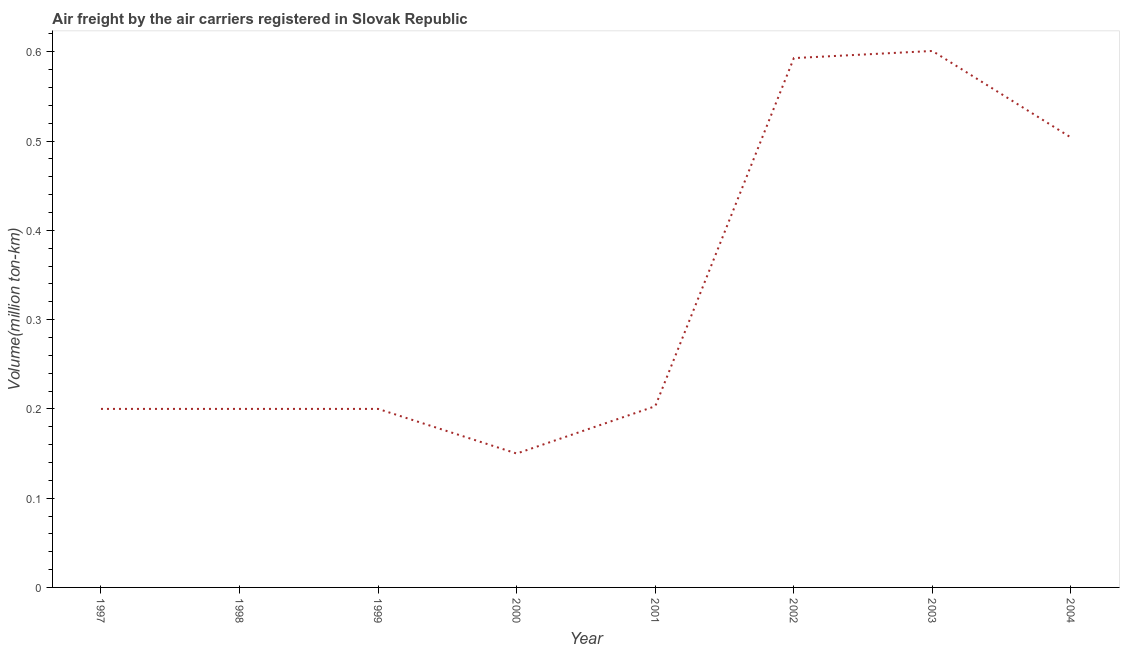What is the air freight in 2002?
Ensure brevity in your answer.  0.59. Across all years, what is the maximum air freight?
Keep it short and to the point. 0.6. In which year was the air freight minimum?
Ensure brevity in your answer.  2000. What is the sum of the air freight?
Keep it short and to the point. 2.65. What is the difference between the air freight in 2002 and 2004?
Make the answer very short. 0.09. What is the average air freight per year?
Make the answer very short. 0.33. What is the median air freight?
Ensure brevity in your answer.  0.2. In how many years, is the air freight greater than 0.18 million ton-km?
Keep it short and to the point. 7. What is the ratio of the air freight in 2000 to that in 2001?
Offer a very short reply. 0.74. Is the difference between the air freight in 1999 and 2002 greater than the difference between any two years?
Provide a succinct answer. No. What is the difference between the highest and the second highest air freight?
Your answer should be very brief. 0.01. Is the sum of the air freight in 2001 and 2003 greater than the maximum air freight across all years?
Offer a very short reply. Yes. What is the difference between the highest and the lowest air freight?
Provide a succinct answer. 0.45. In how many years, is the air freight greater than the average air freight taken over all years?
Offer a terse response. 3. Does the air freight monotonically increase over the years?
Offer a terse response. No. Does the graph contain any zero values?
Provide a succinct answer. No. What is the title of the graph?
Make the answer very short. Air freight by the air carriers registered in Slovak Republic. What is the label or title of the Y-axis?
Provide a short and direct response. Volume(million ton-km). What is the Volume(million ton-km) of 1997?
Keep it short and to the point. 0.2. What is the Volume(million ton-km) of 1998?
Offer a terse response. 0.2. What is the Volume(million ton-km) in 1999?
Your answer should be very brief. 0.2. What is the Volume(million ton-km) in 2001?
Your answer should be very brief. 0.2. What is the Volume(million ton-km) of 2002?
Give a very brief answer. 0.59. What is the Volume(million ton-km) in 2003?
Your answer should be compact. 0.6. What is the Volume(million ton-km) of 2004?
Keep it short and to the point. 0.5. What is the difference between the Volume(million ton-km) in 1997 and 2000?
Offer a very short reply. 0.05. What is the difference between the Volume(million ton-km) in 1997 and 2001?
Provide a succinct answer. -0. What is the difference between the Volume(million ton-km) in 1997 and 2002?
Your response must be concise. -0.39. What is the difference between the Volume(million ton-km) in 1997 and 2003?
Offer a terse response. -0.4. What is the difference between the Volume(million ton-km) in 1997 and 2004?
Offer a terse response. -0.3. What is the difference between the Volume(million ton-km) in 1998 and 1999?
Provide a short and direct response. 0. What is the difference between the Volume(million ton-km) in 1998 and 2000?
Keep it short and to the point. 0.05. What is the difference between the Volume(million ton-km) in 1998 and 2001?
Keep it short and to the point. -0. What is the difference between the Volume(million ton-km) in 1998 and 2002?
Your answer should be compact. -0.39. What is the difference between the Volume(million ton-km) in 1998 and 2003?
Your response must be concise. -0.4. What is the difference between the Volume(million ton-km) in 1998 and 2004?
Give a very brief answer. -0.3. What is the difference between the Volume(million ton-km) in 1999 and 2000?
Your answer should be compact. 0.05. What is the difference between the Volume(million ton-km) in 1999 and 2001?
Keep it short and to the point. -0. What is the difference between the Volume(million ton-km) in 1999 and 2002?
Your answer should be very brief. -0.39. What is the difference between the Volume(million ton-km) in 1999 and 2003?
Ensure brevity in your answer.  -0.4. What is the difference between the Volume(million ton-km) in 1999 and 2004?
Your answer should be compact. -0.3. What is the difference between the Volume(million ton-km) in 2000 and 2001?
Your response must be concise. -0.05. What is the difference between the Volume(million ton-km) in 2000 and 2002?
Keep it short and to the point. -0.44. What is the difference between the Volume(million ton-km) in 2000 and 2003?
Your response must be concise. -0.45. What is the difference between the Volume(million ton-km) in 2000 and 2004?
Offer a very short reply. -0.35. What is the difference between the Volume(million ton-km) in 2001 and 2002?
Your response must be concise. -0.39. What is the difference between the Volume(million ton-km) in 2001 and 2003?
Keep it short and to the point. -0.4. What is the difference between the Volume(million ton-km) in 2001 and 2004?
Your answer should be compact. -0.3. What is the difference between the Volume(million ton-km) in 2002 and 2003?
Offer a very short reply. -0.01. What is the difference between the Volume(million ton-km) in 2002 and 2004?
Make the answer very short. 0.09. What is the difference between the Volume(million ton-km) in 2003 and 2004?
Provide a short and direct response. 0.1. What is the ratio of the Volume(million ton-km) in 1997 to that in 1998?
Your response must be concise. 1. What is the ratio of the Volume(million ton-km) in 1997 to that in 1999?
Offer a terse response. 1. What is the ratio of the Volume(million ton-km) in 1997 to that in 2000?
Your answer should be very brief. 1.33. What is the ratio of the Volume(million ton-km) in 1997 to that in 2002?
Make the answer very short. 0.34. What is the ratio of the Volume(million ton-km) in 1997 to that in 2003?
Give a very brief answer. 0.33. What is the ratio of the Volume(million ton-km) in 1997 to that in 2004?
Provide a succinct answer. 0.4. What is the ratio of the Volume(million ton-km) in 1998 to that in 2000?
Make the answer very short. 1.33. What is the ratio of the Volume(million ton-km) in 1998 to that in 2002?
Offer a terse response. 0.34. What is the ratio of the Volume(million ton-km) in 1998 to that in 2003?
Make the answer very short. 0.33. What is the ratio of the Volume(million ton-km) in 1998 to that in 2004?
Provide a succinct answer. 0.4. What is the ratio of the Volume(million ton-km) in 1999 to that in 2000?
Keep it short and to the point. 1.33. What is the ratio of the Volume(million ton-km) in 1999 to that in 2001?
Give a very brief answer. 0.98. What is the ratio of the Volume(million ton-km) in 1999 to that in 2002?
Your answer should be compact. 0.34. What is the ratio of the Volume(million ton-km) in 1999 to that in 2003?
Your response must be concise. 0.33. What is the ratio of the Volume(million ton-km) in 1999 to that in 2004?
Offer a terse response. 0.4. What is the ratio of the Volume(million ton-km) in 2000 to that in 2001?
Give a very brief answer. 0.74. What is the ratio of the Volume(million ton-km) in 2000 to that in 2002?
Your answer should be compact. 0.25. What is the ratio of the Volume(million ton-km) in 2000 to that in 2004?
Make the answer very short. 0.3. What is the ratio of the Volume(million ton-km) in 2001 to that in 2002?
Your answer should be very brief. 0.34. What is the ratio of the Volume(million ton-km) in 2001 to that in 2003?
Ensure brevity in your answer.  0.34. What is the ratio of the Volume(million ton-km) in 2001 to that in 2004?
Make the answer very short. 0.4. What is the ratio of the Volume(million ton-km) in 2002 to that in 2003?
Your answer should be compact. 0.99. What is the ratio of the Volume(million ton-km) in 2002 to that in 2004?
Offer a very short reply. 1.18. What is the ratio of the Volume(million ton-km) in 2003 to that in 2004?
Your answer should be very brief. 1.19. 